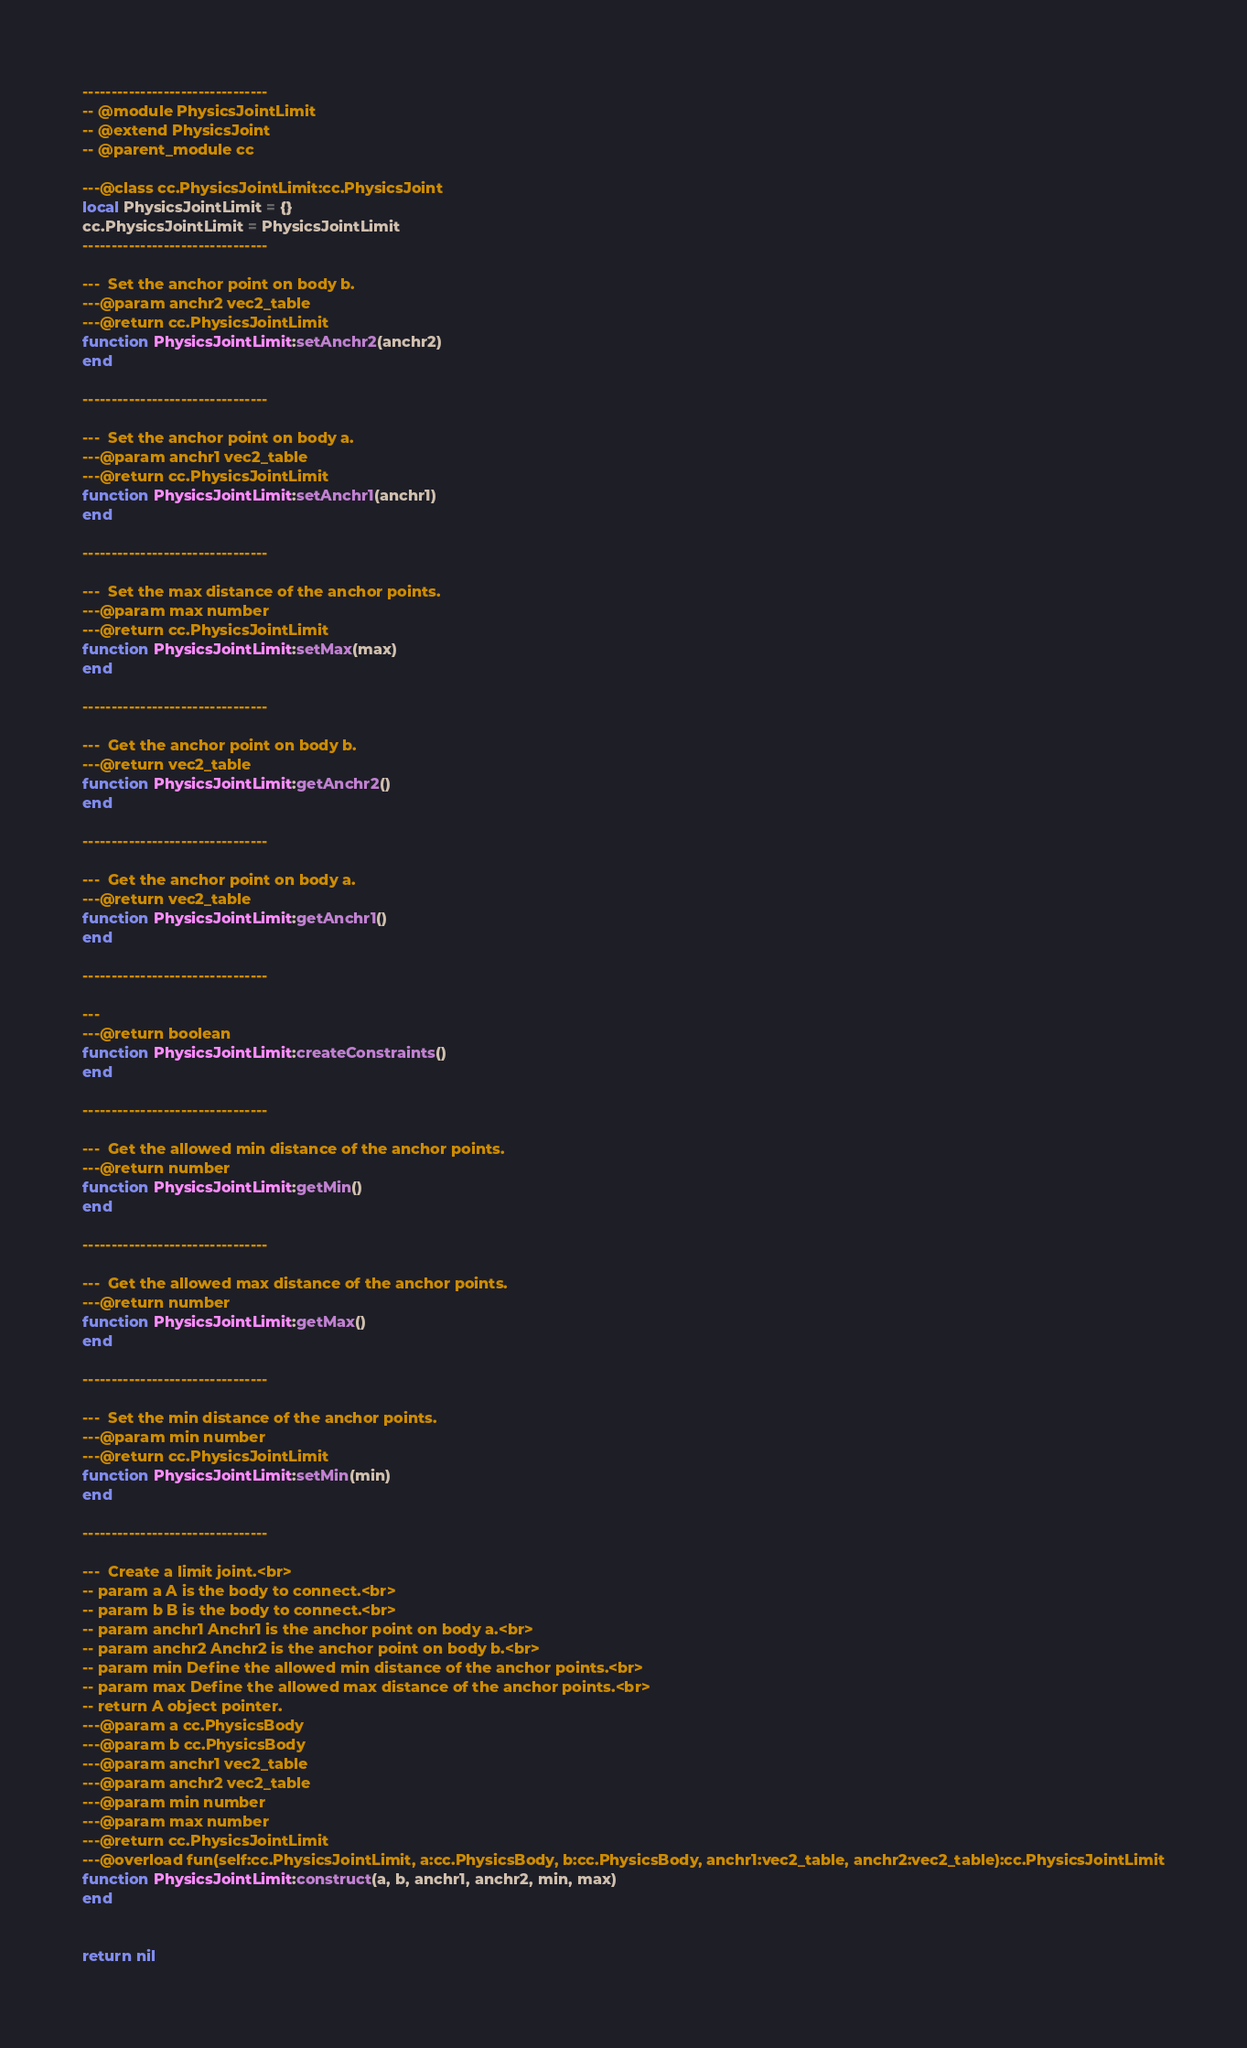Convert code to text. <code><loc_0><loc_0><loc_500><loc_500><_Lua_>
--------------------------------
-- @module PhysicsJointLimit
-- @extend PhysicsJoint
-- @parent_module cc

---@class cc.PhysicsJointLimit:cc.PhysicsJoint
local PhysicsJointLimit = {}
cc.PhysicsJointLimit = PhysicsJointLimit
--------------------------------

---  Set the anchor point on body b.
---@param anchr2 vec2_table
---@return cc.PhysicsJointLimit
function PhysicsJointLimit:setAnchr2(anchr2)
end

--------------------------------

---  Set the anchor point on body a.
---@param anchr1 vec2_table
---@return cc.PhysicsJointLimit
function PhysicsJointLimit:setAnchr1(anchr1)
end

--------------------------------

---  Set the max distance of the anchor points.
---@param max number
---@return cc.PhysicsJointLimit
function PhysicsJointLimit:setMax(max)
end

--------------------------------

---  Get the anchor point on body b.
---@return vec2_table
function PhysicsJointLimit:getAnchr2()
end

--------------------------------

---  Get the anchor point on body a.
---@return vec2_table
function PhysicsJointLimit:getAnchr1()
end

--------------------------------

--- 
---@return boolean
function PhysicsJointLimit:createConstraints()
end

--------------------------------

---  Get the allowed min distance of the anchor points.
---@return number
function PhysicsJointLimit:getMin()
end

--------------------------------

---  Get the allowed max distance of the anchor points.
---@return number
function PhysicsJointLimit:getMax()
end

--------------------------------

---  Set the min distance of the anchor points.
---@param min number
---@return cc.PhysicsJointLimit
function PhysicsJointLimit:setMin(min)
end

--------------------------------

---  Create a limit joint.<br>
-- param a A is the body to connect.<br>
-- param b B is the body to connect.<br>
-- param anchr1 Anchr1 is the anchor point on body a.<br>
-- param anchr2 Anchr2 is the anchor point on body b.<br>
-- param min Define the allowed min distance of the anchor points.<br>
-- param max Define the allowed max distance of the anchor points.<br>
-- return A object pointer.
---@param a cc.PhysicsBody
---@param b cc.PhysicsBody
---@param anchr1 vec2_table
---@param anchr2 vec2_table
---@param min number
---@param max number
---@return cc.PhysicsJointLimit
---@overload fun(self:cc.PhysicsJointLimit, a:cc.PhysicsBody, b:cc.PhysicsBody, anchr1:vec2_table, anchr2:vec2_table):cc.PhysicsJointLimit
function PhysicsJointLimit:construct(a, b, anchr1, anchr2, min, max)
end


return nil
</code> 